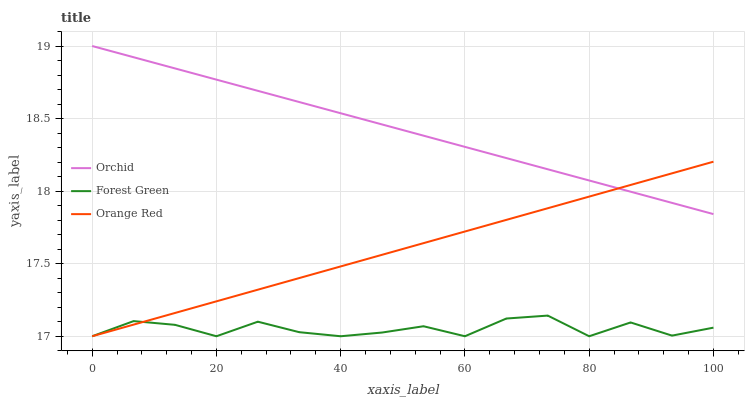Does Forest Green have the minimum area under the curve?
Answer yes or no. Yes. Does Orchid have the maximum area under the curve?
Answer yes or no. Yes. Does Orange Red have the minimum area under the curve?
Answer yes or no. No. Does Orange Red have the maximum area under the curve?
Answer yes or no. No. Is Orange Red the smoothest?
Answer yes or no. Yes. Is Forest Green the roughest?
Answer yes or no. Yes. Is Orchid the smoothest?
Answer yes or no. No. Is Orchid the roughest?
Answer yes or no. No. Does Orchid have the lowest value?
Answer yes or no. No. Does Orchid have the highest value?
Answer yes or no. Yes. Does Orange Red have the highest value?
Answer yes or no. No. Is Forest Green less than Orchid?
Answer yes or no. Yes. Is Orchid greater than Forest Green?
Answer yes or no. Yes. Does Forest Green intersect Orange Red?
Answer yes or no. Yes. Is Forest Green less than Orange Red?
Answer yes or no. No. Is Forest Green greater than Orange Red?
Answer yes or no. No. Does Forest Green intersect Orchid?
Answer yes or no. No. 